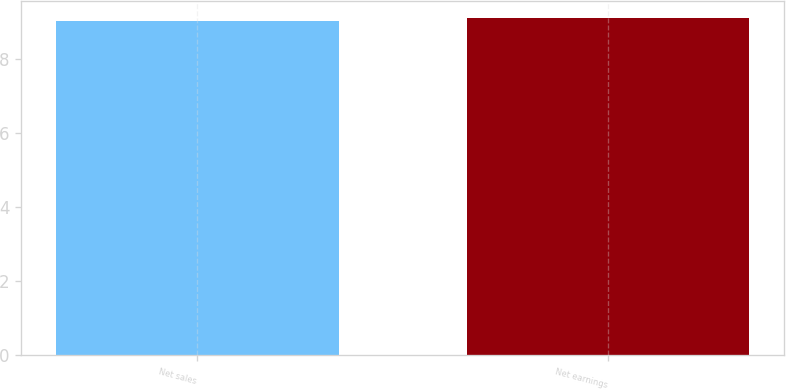Convert chart. <chart><loc_0><loc_0><loc_500><loc_500><bar_chart><fcel>Net sales<fcel>Net earnings<nl><fcel>9<fcel>9.1<nl></chart> 